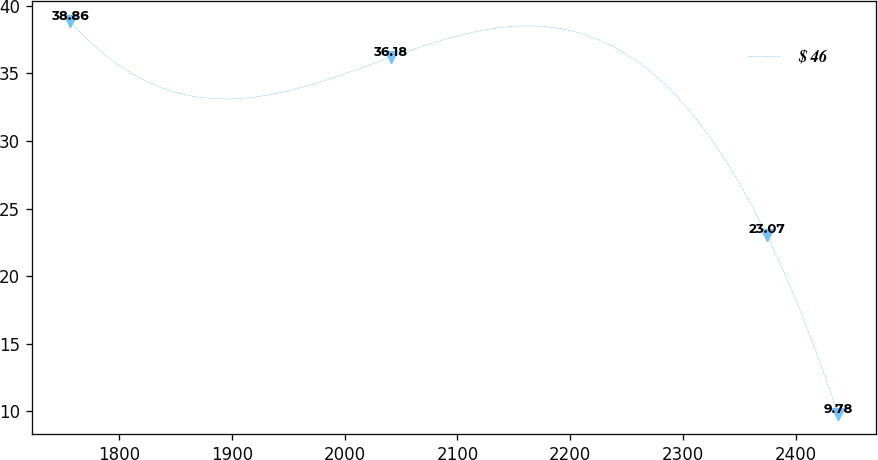Convert chart to OTSL. <chart><loc_0><loc_0><loc_500><loc_500><line_chart><ecel><fcel>$ 46<nl><fcel>1756.6<fcel>38.86<nl><fcel>2040.8<fcel>36.18<nl><fcel>2374.23<fcel>23.07<nl><fcel>2437.5<fcel>9.78<nl></chart> 